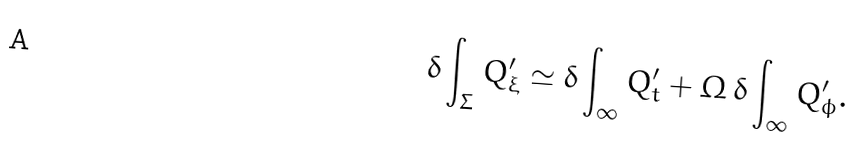<formula> <loc_0><loc_0><loc_500><loc_500>\delta \int _ { \Sigma } Q ^ { \prime } _ { \xi } \simeq \delta \int _ { \infty } Q ^ { \prime } _ { t } + \Omega \, \delta \int _ { \infty } Q ^ { \prime } _ { \phi } .</formula> 